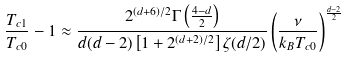<formula> <loc_0><loc_0><loc_500><loc_500>\frac { T _ { c 1 } } { T _ { c 0 } } - 1 \approx \frac { 2 ^ { ( d + 6 ) / 2 } \Gamma \left ( \frac { 4 - d } { 2 } \right ) } { d ( d - 2 ) \left [ 1 + 2 ^ { ( d + 2 ) / 2 } \right ] \zeta ( d / 2 ) } \left ( \frac { \nu } { k _ { B } T _ { c 0 } } \right ) ^ { \frac { d - 2 } { 2 } }</formula> 